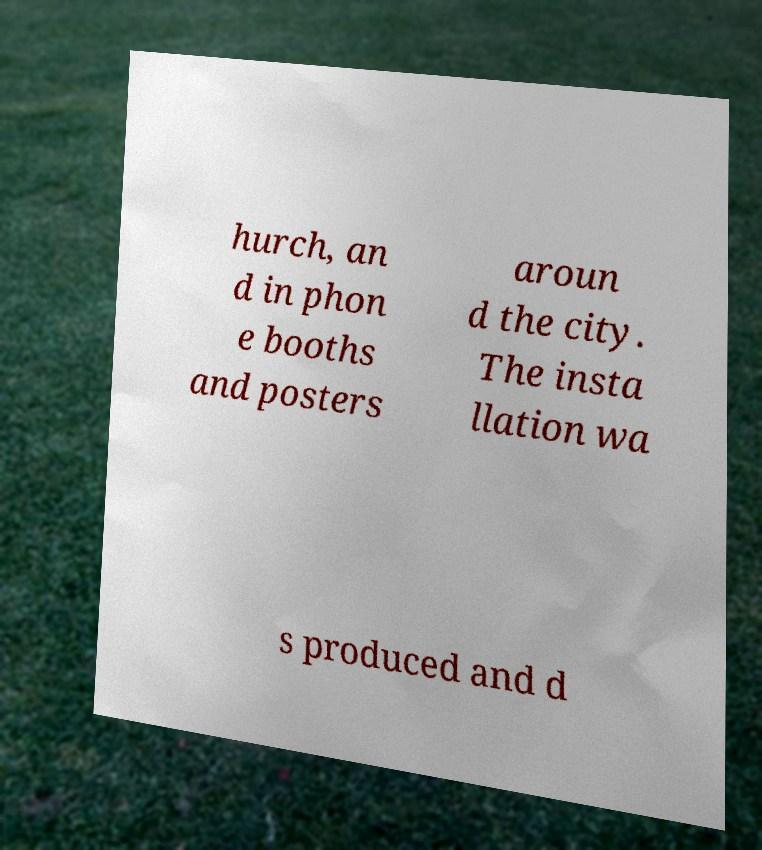Could you assist in decoding the text presented in this image and type it out clearly? hurch, an d in phon e booths and posters aroun d the city. The insta llation wa s produced and d 